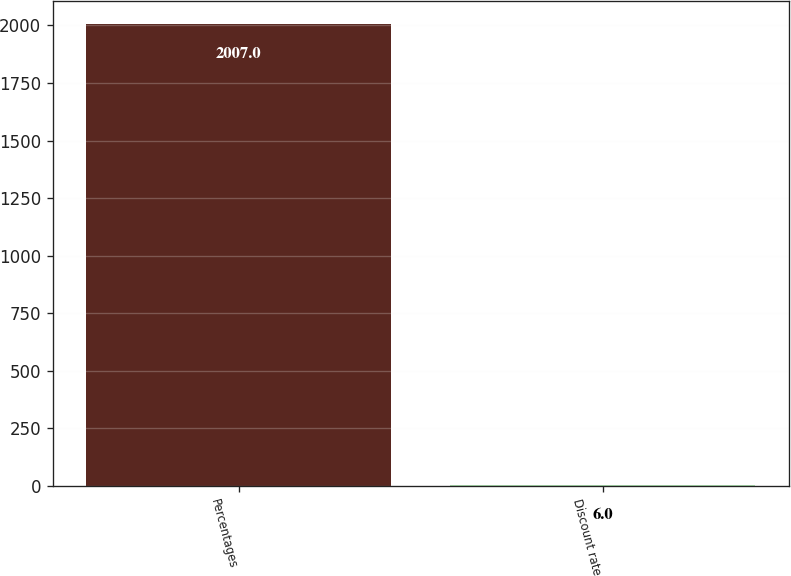<chart> <loc_0><loc_0><loc_500><loc_500><bar_chart><fcel>Percentages<fcel>Discount rate<nl><fcel>2007<fcel>6<nl></chart> 